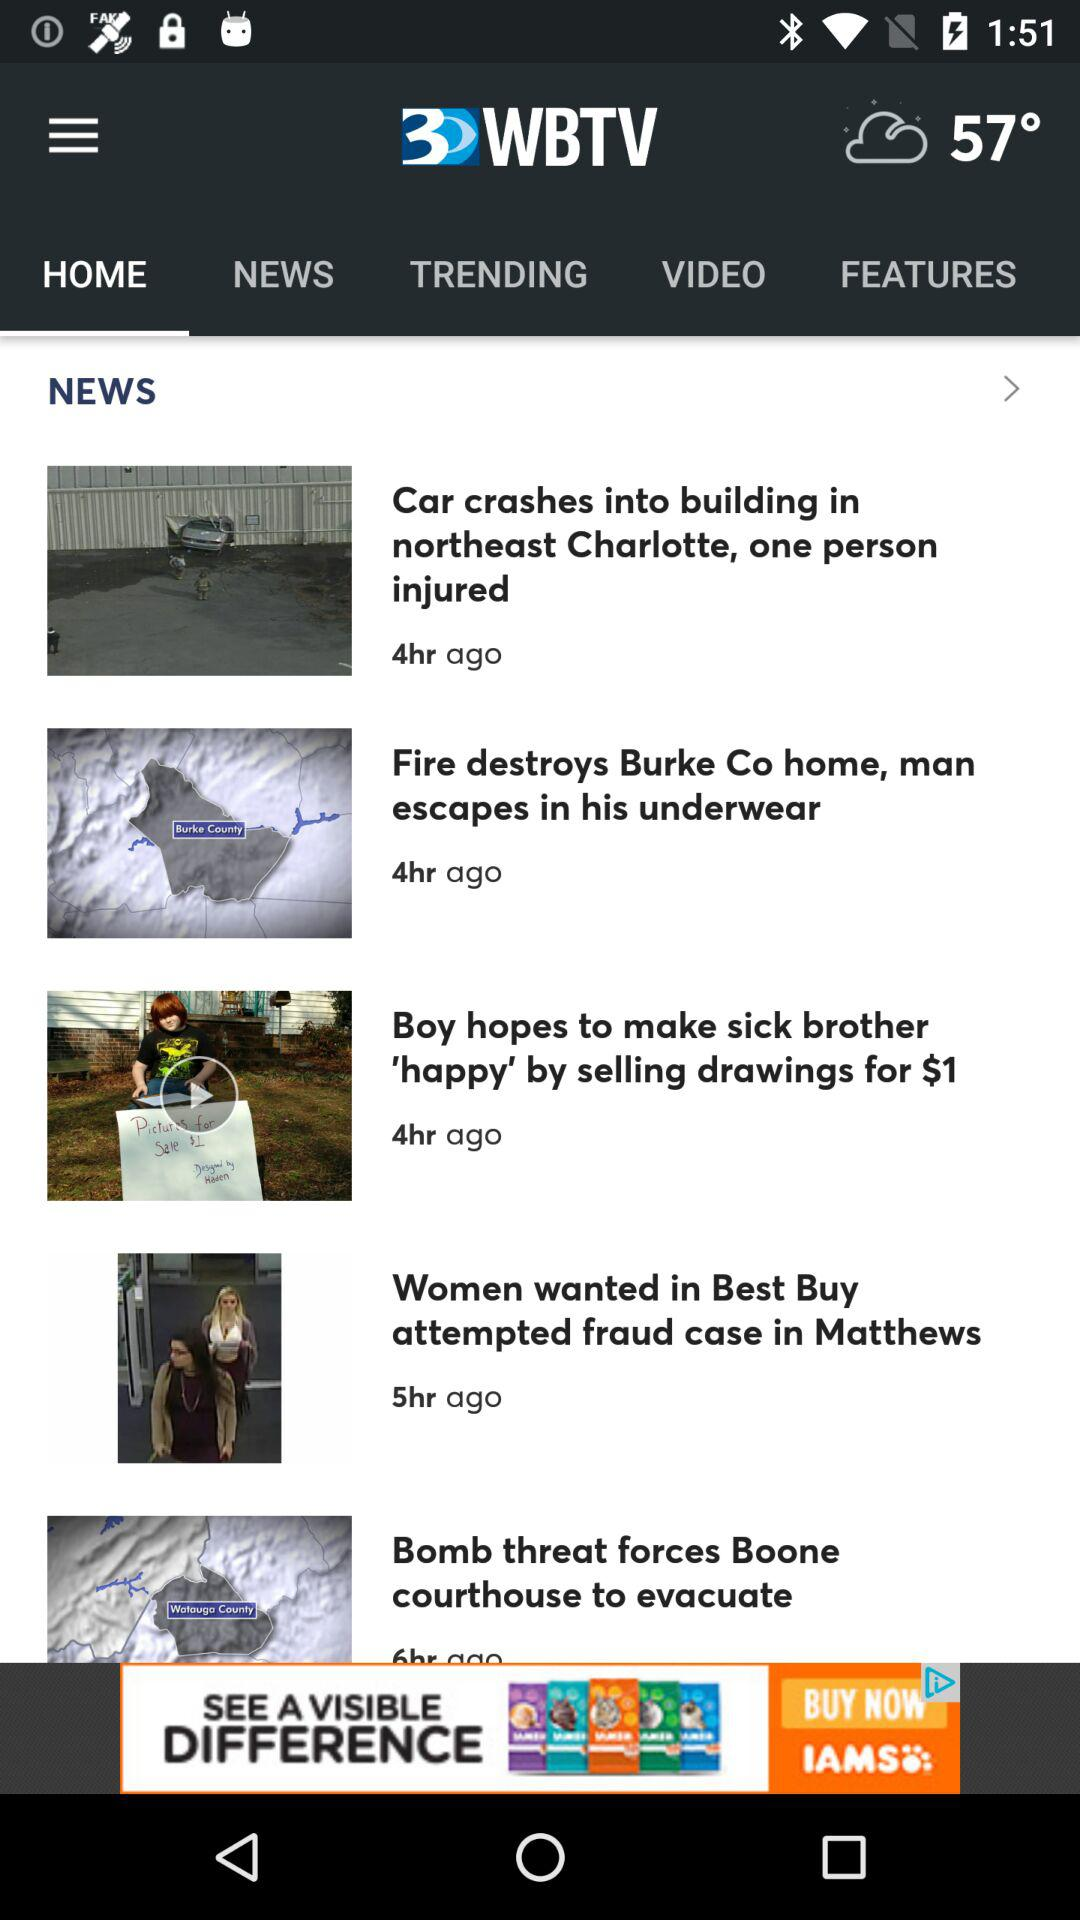What is the temperature? The temperature is 57 degrees. 